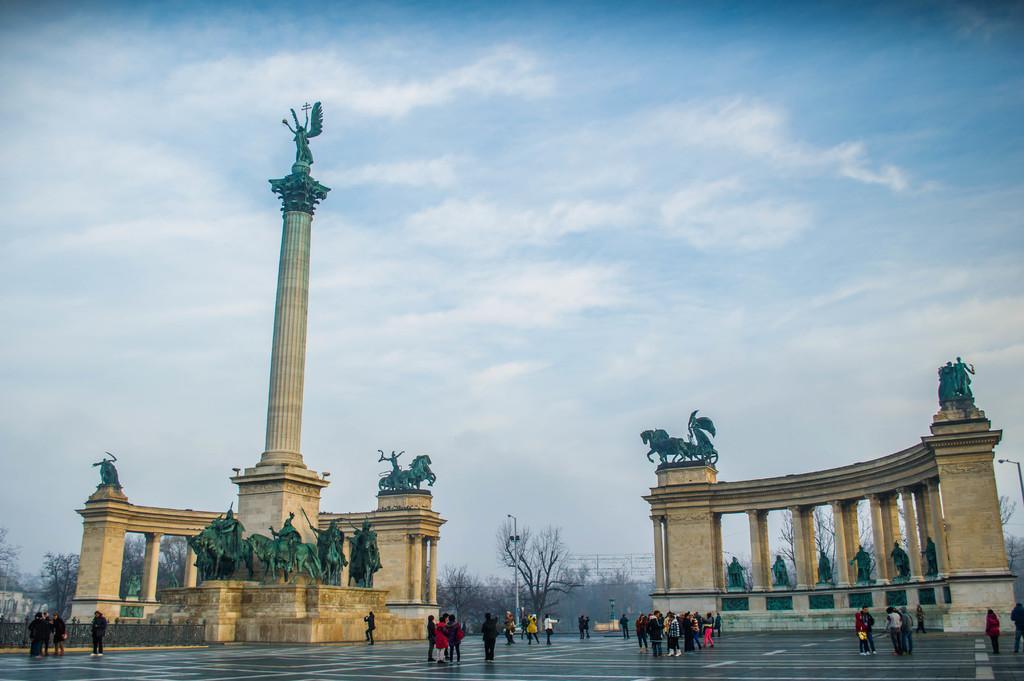How would you summarize this image in a sentence or two? In this image, on the right side, we can see some pillars with sculpture. On the right side, we can see a street light. On the right side, we can also see some trees and plants, electric wires. On the left side, we can see a pole, statue, pillars, we can also see a group of people standing on the land, trees, plants, building. In the middle of the image, we can see a group of people, street light, trees, plants. At the top, we can see a sky which is a bit cloudy, at the bottom, we can see a land. 